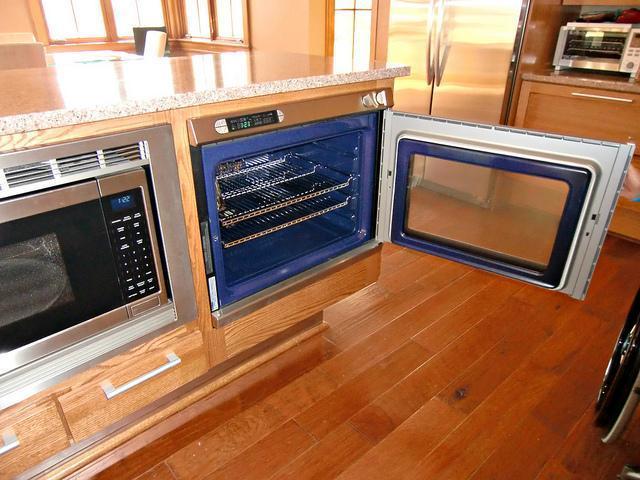How many ovens are there?
Give a very brief answer. 2. How many red cars are there?
Give a very brief answer. 0. 